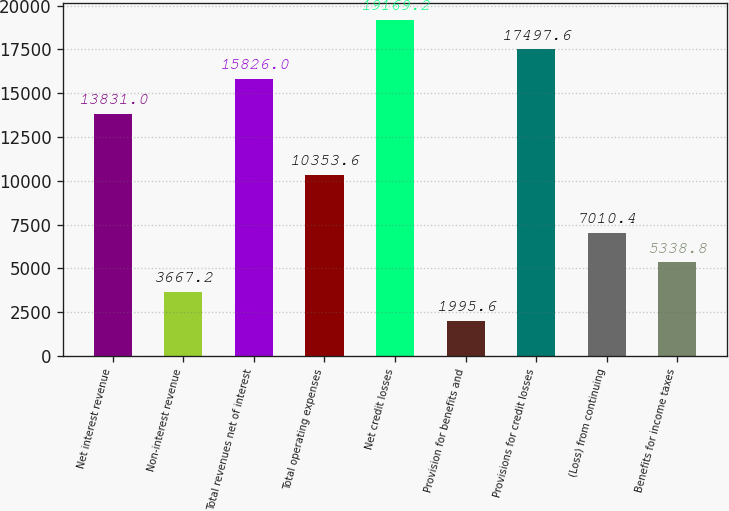Convert chart to OTSL. <chart><loc_0><loc_0><loc_500><loc_500><bar_chart><fcel>Net interest revenue<fcel>Non-interest revenue<fcel>Total revenues net of interest<fcel>Total operating expenses<fcel>Net credit losses<fcel>Provision for benefits and<fcel>Provisions for credit losses<fcel>(Loss) from continuing<fcel>Benefits for income taxes<nl><fcel>13831<fcel>3667.2<fcel>15826<fcel>10353.6<fcel>19169.2<fcel>1995.6<fcel>17497.6<fcel>7010.4<fcel>5338.8<nl></chart> 